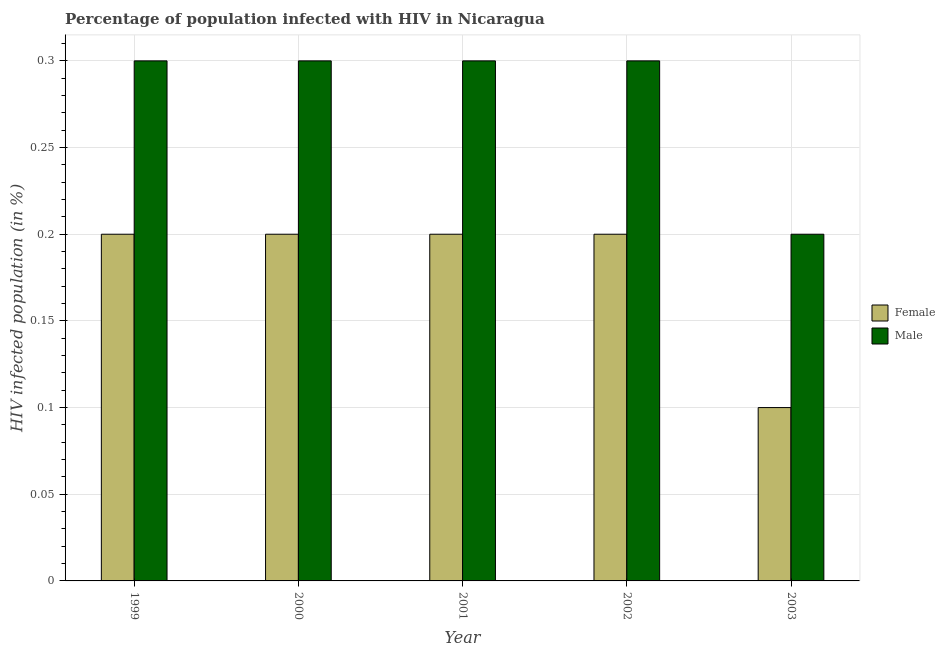How many groups of bars are there?
Keep it short and to the point. 5. Are the number of bars per tick equal to the number of legend labels?
Ensure brevity in your answer.  Yes. How many bars are there on the 5th tick from the right?
Ensure brevity in your answer.  2. What is the label of the 4th group of bars from the left?
Offer a very short reply. 2002. In how many cases, is the number of bars for a given year not equal to the number of legend labels?
Make the answer very short. 0. What is the percentage of males who are infected with hiv in 2000?
Your response must be concise. 0.3. Across all years, what is the maximum percentage of females who are infected with hiv?
Your answer should be very brief. 0.2. What is the total percentage of males who are infected with hiv in the graph?
Offer a terse response. 1.4. What is the difference between the percentage of males who are infected with hiv in 2000 and that in 2001?
Provide a succinct answer. 0. What is the difference between the percentage of males who are infected with hiv in 2003 and the percentage of females who are infected with hiv in 2002?
Offer a very short reply. -0.1. What is the average percentage of males who are infected with hiv per year?
Your response must be concise. 0.28. In the year 2002, what is the difference between the percentage of males who are infected with hiv and percentage of females who are infected with hiv?
Make the answer very short. 0. What is the ratio of the percentage of females who are infected with hiv in 2000 to that in 2002?
Ensure brevity in your answer.  1. What is the difference between the highest and the second highest percentage of females who are infected with hiv?
Your response must be concise. 0. In how many years, is the percentage of females who are infected with hiv greater than the average percentage of females who are infected with hiv taken over all years?
Your answer should be very brief. 4. Is the sum of the percentage of males who are infected with hiv in 2001 and 2003 greater than the maximum percentage of females who are infected with hiv across all years?
Provide a succinct answer. Yes. What does the 1st bar from the left in 2002 represents?
Provide a succinct answer. Female. What does the 2nd bar from the right in 2003 represents?
Offer a very short reply. Female. Are all the bars in the graph horizontal?
Provide a succinct answer. No. What is the difference between two consecutive major ticks on the Y-axis?
Your response must be concise. 0.05. Are the values on the major ticks of Y-axis written in scientific E-notation?
Offer a very short reply. No. Does the graph contain any zero values?
Make the answer very short. No. Does the graph contain grids?
Your answer should be compact. Yes. What is the title of the graph?
Ensure brevity in your answer.  Percentage of population infected with HIV in Nicaragua. Does "Crop" appear as one of the legend labels in the graph?
Ensure brevity in your answer.  No. What is the label or title of the Y-axis?
Give a very brief answer. HIV infected population (in %). What is the HIV infected population (in %) of Female in 2000?
Provide a succinct answer. 0.2. What is the HIV infected population (in %) in Male in 2000?
Ensure brevity in your answer.  0.3. What is the HIV infected population (in %) of Male in 2001?
Ensure brevity in your answer.  0.3. Across all years, what is the maximum HIV infected population (in %) of Female?
Provide a short and direct response. 0.2. Across all years, what is the minimum HIV infected population (in %) of Female?
Your answer should be very brief. 0.1. Across all years, what is the minimum HIV infected population (in %) in Male?
Provide a succinct answer. 0.2. What is the difference between the HIV infected population (in %) of Female in 1999 and that in 2002?
Your answer should be very brief. 0. What is the difference between the HIV infected population (in %) in Female in 1999 and that in 2003?
Your answer should be compact. 0.1. What is the difference between the HIV infected population (in %) of Male in 1999 and that in 2003?
Make the answer very short. 0.1. What is the difference between the HIV infected population (in %) of Male in 2000 and that in 2003?
Your answer should be very brief. 0.1. What is the difference between the HIV infected population (in %) of Male in 2001 and that in 2002?
Provide a short and direct response. 0. What is the difference between the HIV infected population (in %) in Male in 2001 and that in 2003?
Keep it short and to the point. 0.1. What is the difference between the HIV infected population (in %) in Female in 1999 and the HIV infected population (in %) in Male in 2000?
Keep it short and to the point. -0.1. What is the difference between the HIV infected population (in %) of Female in 1999 and the HIV infected population (in %) of Male in 2001?
Your answer should be very brief. -0.1. What is the difference between the HIV infected population (in %) in Female in 1999 and the HIV infected population (in %) in Male in 2003?
Your answer should be very brief. 0. What is the difference between the HIV infected population (in %) of Female in 2000 and the HIV infected population (in %) of Male in 2001?
Make the answer very short. -0.1. What is the average HIV infected population (in %) of Female per year?
Your answer should be compact. 0.18. What is the average HIV infected population (in %) in Male per year?
Ensure brevity in your answer.  0.28. In the year 1999, what is the difference between the HIV infected population (in %) of Female and HIV infected population (in %) of Male?
Your answer should be very brief. -0.1. In the year 2000, what is the difference between the HIV infected population (in %) in Female and HIV infected population (in %) in Male?
Offer a terse response. -0.1. In the year 2001, what is the difference between the HIV infected population (in %) in Female and HIV infected population (in %) in Male?
Your answer should be compact. -0.1. What is the ratio of the HIV infected population (in %) in Female in 1999 to that in 2000?
Ensure brevity in your answer.  1. What is the ratio of the HIV infected population (in %) in Male in 1999 to that in 2002?
Keep it short and to the point. 1. What is the ratio of the HIV infected population (in %) in Male in 1999 to that in 2003?
Offer a very short reply. 1.5. What is the ratio of the HIV infected population (in %) of Female in 2000 to that in 2001?
Your answer should be very brief. 1. What is the ratio of the HIV infected population (in %) in Female in 2000 to that in 2002?
Your answer should be compact. 1. What is the ratio of the HIV infected population (in %) of Male in 2000 to that in 2003?
Offer a terse response. 1.5. What is the ratio of the HIV infected population (in %) in Male in 2001 to that in 2003?
Your answer should be compact. 1.5. What is the ratio of the HIV infected population (in %) in Female in 2002 to that in 2003?
Offer a terse response. 2. What is the difference between the highest and the lowest HIV infected population (in %) of Male?
Provide a short and direct response. 0.1. 